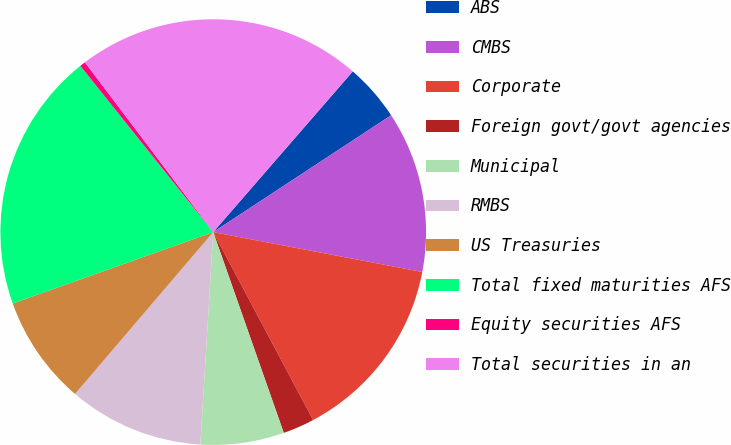Convert chart to OTSL. <chart><loc_0><loc_0><loc_500><loc_500><pie_chart><fcel>ABS<fcel>CMBS<fcel>Corporate<fcel>Foreign govt/govt agencies<fcel>Municipal<fcel>RMBS<fcel>US Treasuries<fcel>Total fixed maturities AFS<fcel>Equity securities AFS<fcel>Total securities in an<nl><fcel>4.37%<fcel>12.25%<fcel>14.22%<fcel>2.4%<fcel>6.34%<fcel>10.28%<fcel>8.31%<fcel>19.71%<fcel>0.43%<fcel>21.68%<nl></chart> 